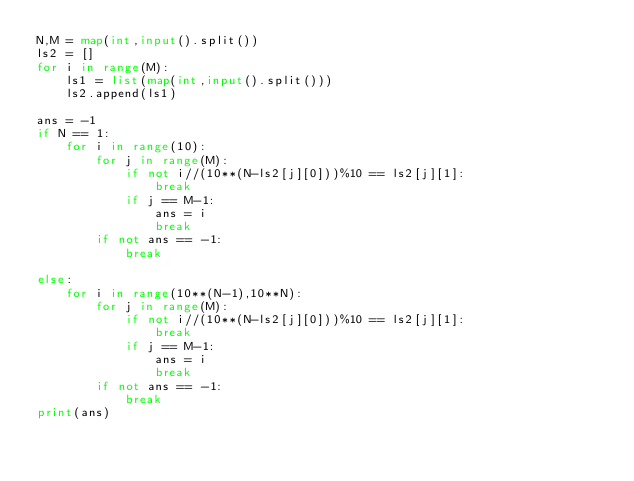<code> <loc_0><loc_0><loc_500><loc_500><_Python_>N,M = map(int,input().split())
ls2 = []
for i in range(M):
    ls1 = list(map(int,input().split()))
    ls2.append(ls1)

ans = -1
if N == 1:
    for i in range(10):
        for j in range(M):
            if not i//(10**(N-ls2[j][0]))%10 == ls2[j][1]:
                break
            if j == M-1:
                ans = i
                break
        if not ans == -1:
            break   

else:
    for i in range(10**(N-1),10**N):
        for j in range(M):
            if not i//(10**(N-ls2[j][0]))%10 == ls2[j][1]:
                break
            if j == M-1:
                ans = i
                break
        if not ans == -1:
            break
print(ans)          
</code> 